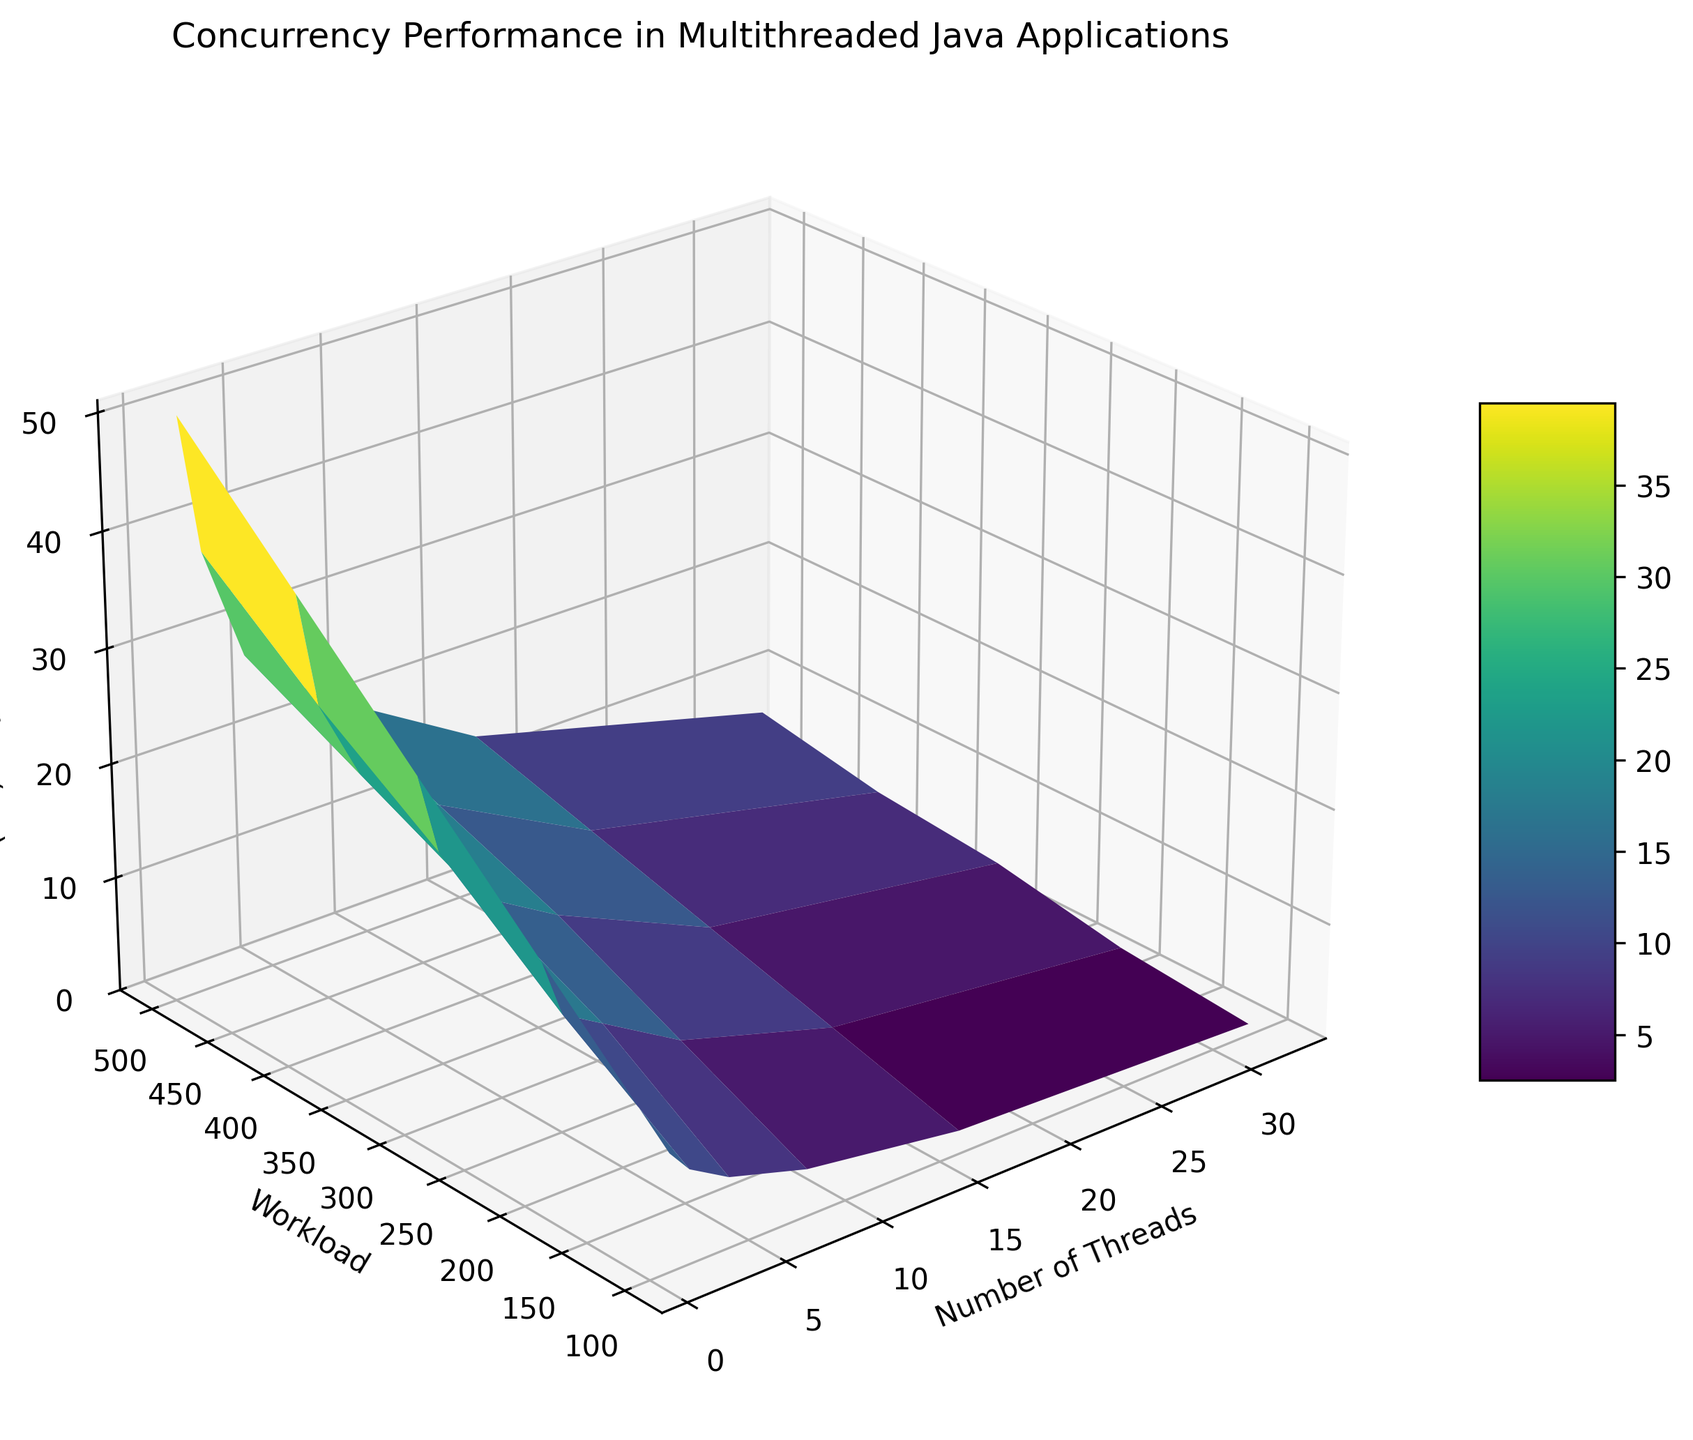Which number of threads results in the least execution time for a workload of 500? From the figure, locate the surface point corresponding to a workload of 500 and compare the execution times across different number of threads. Note that as the number of threads increases, the execution time decreases.
Answer: 32 How does the execution time change when the number of threads doubles from 4 to 8 for a workload of 400? In the figure, identify the points where the workload is 400 for 4 and 8 threads. The execution time decreases from 23 ms to 18 ms when doubling the number of threads.
Answer: It decreases by 5 ms Which workload has the most significant reduction in execution time when going from 2 threads to 16 threads? Check the execution time for each workload for 2 threads and 16 threads, and then calculate the reduction for each workload. The workload of 100 has the most significant reduction from 8 ms to 2 ms, a reduction of 6 ms.
Answer: Workload of 100 What is the execution time for the maximum number of threads (32) with the smallest workload (100)? Look at the corner of the surface where the number of threads is 32 and the workload is 100. The execution time at this point is 1 ms.
Answer: 1 ms For a workload of 300, how does the execution time compare between using 1 thread and 16 threads? Locate the points on the surface plot where the workload is 300 for 1 and 16 threads. The execution time with 1 thread is 30 ms and with 16 threads it is 8 ms.
Answer: It decreases from 30 ms to 8 ms when using 16 threads What trend do you observe in execution time as the number of threads increases for a fixed workload of 100? Analyze the surface plot along the line where the workload is 100. The trend shows that execution time consistently decreases as the number of threads increases.
Answer: Execution time decreases When the workload is increased from 200 to 500 while using 4 threads, how does the execution time change? Identify the points for a workload of 200 and 500 with 4 threads on the plot. The execution time increases from 13 ms to 28 ms.
Answer: The execution time increases by 15 ms What is the visual effect on the surface color as the execution time decreases? Observe the color gradient on the surface plot. The color changes from darker shades to lighter shades as the execution time decreases, indicating lower execution times.
Answer: Color transitions to lighter shades Which combination of threads and workload yields an execution time of approximately 14 ms? Examine the surface plot where the execution time is around 14 ms. This occurs at two points: 8 threads with a workload of 300 and 16 threads with a workload of 500.
Answer: 8 threads with a workload of 300 or 16 threads with a workload of 500 